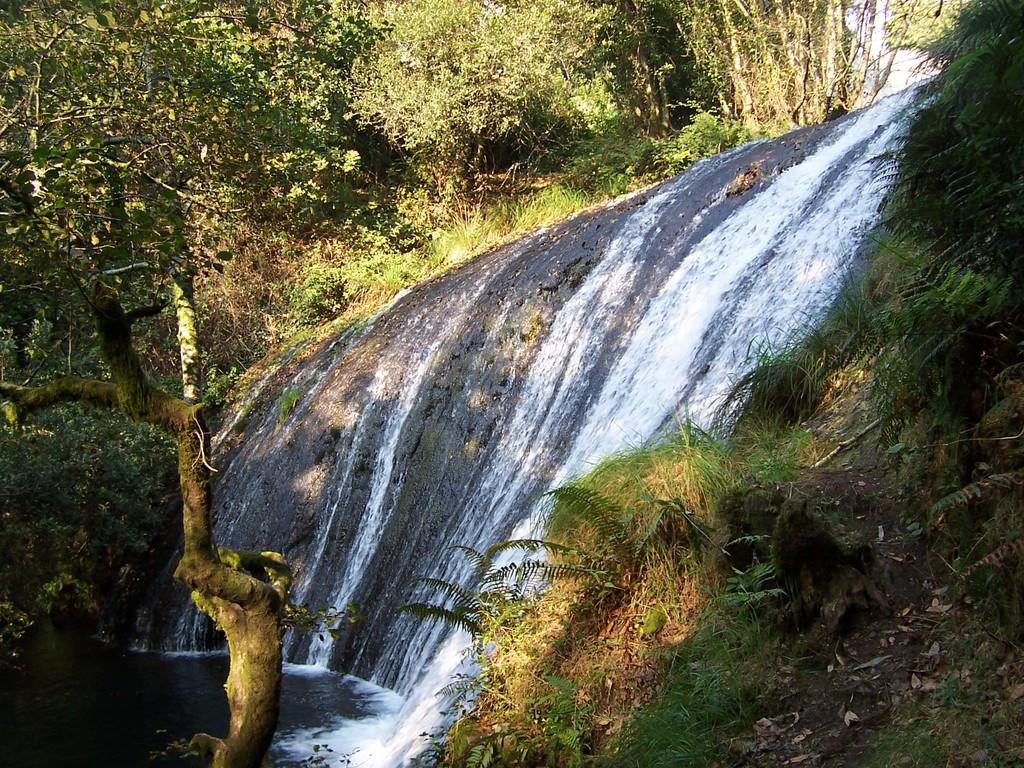What natural feature is the main subject of the image? There is a waterfall in the image. What type of vegetation can be seen in the background of the image? There are trees in the background of the image. Can you see a frog sitting on the tramp in the image? There is no tramp or frog present in the image. 